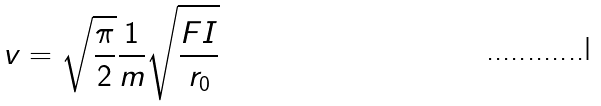Convert formula to latex. <formula><loc_0><loc_0><loc_500><loc_500>v = \sqrt { \frac { \pi } { 2 } } \frac { 1 } { m } \sqrt { \frac { F I } { r _ { 0 } } }</formula> 